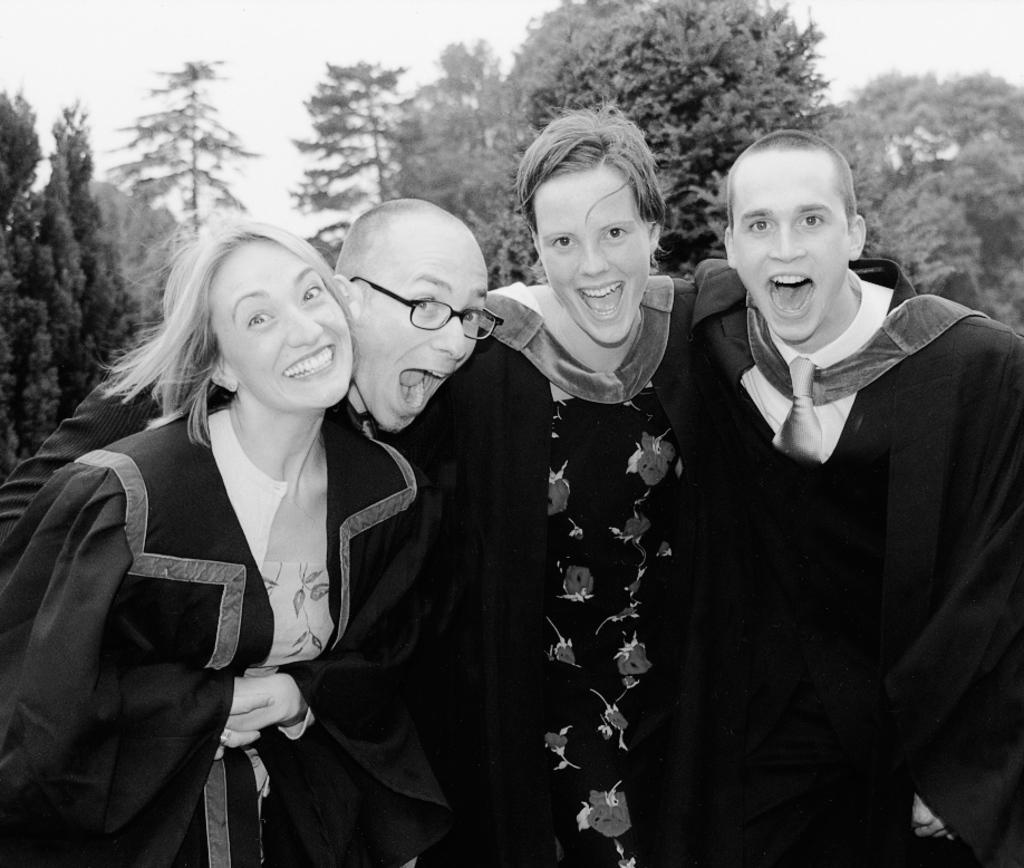How many people are in the image? There are four persons in the image. What are the persons wearing? The persons are wearing black coats. What can be seen in the background of the image? There are many trees in the background of the image. What is visible at the top of the image? The sky is visible at the top of the image. Can you tell me how many ladybugs are on the persons' coats in the image? There are no ladybugs visible on the persons' coats in the image. What type of picture is the ladybug holding in the image? There is no ladybug or picture present in the image. 